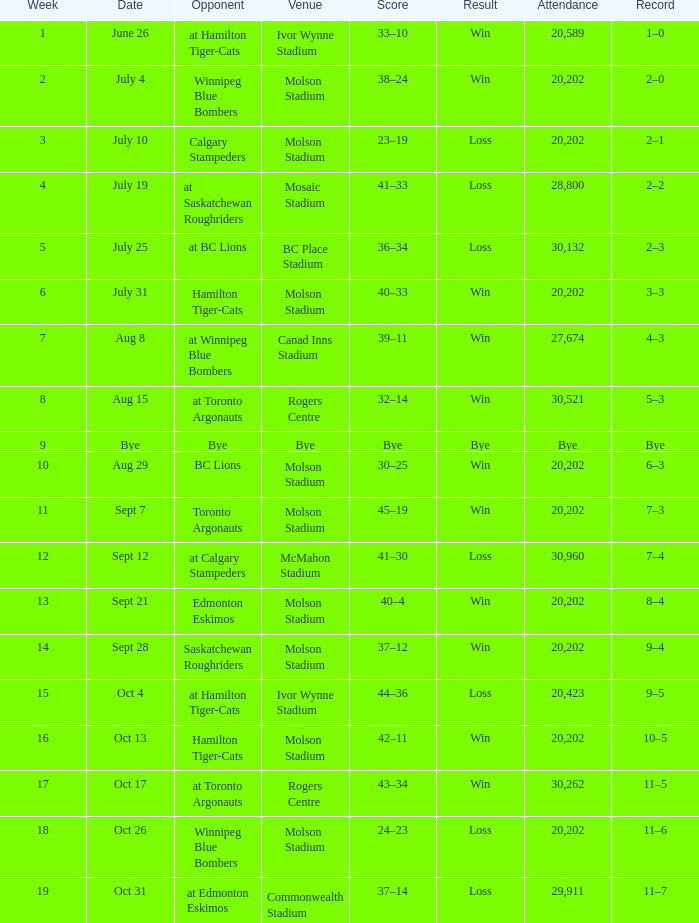What is Opponent, when Result is Loss, and when Venue is Mosaic Stadium? At saskatchewan roughriders. 